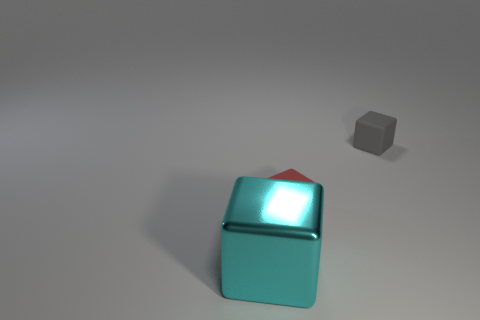What is the size of the cyan thing that is on the left side of the small red thing?
Make the answer very short. Large. There is a tiny block in front of the tiny gray cube; what is its material?
Your response must be concise. Rubber. How many gray matte objects have the same shape as the red object?
Ensure brevity in your answer.  1. What is the material of the big cyan block that is to the left of the thing right of the red thing?
Provide a succinct answer. Metal. Are there any tiny red cubes made of the same material as the tiny gray block?
Provide a short and direct response. Yes. The metal object is what shape?
Your answer should be compact. Cube. How many small red things are there?
Offer a very short reply. 1. What is the color of the tiny thing that is on the left side of the tiny matte thing that is on the right side of the small red matte thing?
Offer a very short reply. Red. There is a rubber block that is the same size as the red rubber object; what is its color?
Offer a very short reply. Gray. Is there a tiny green shiny object?
Give a very brief answer. No. 